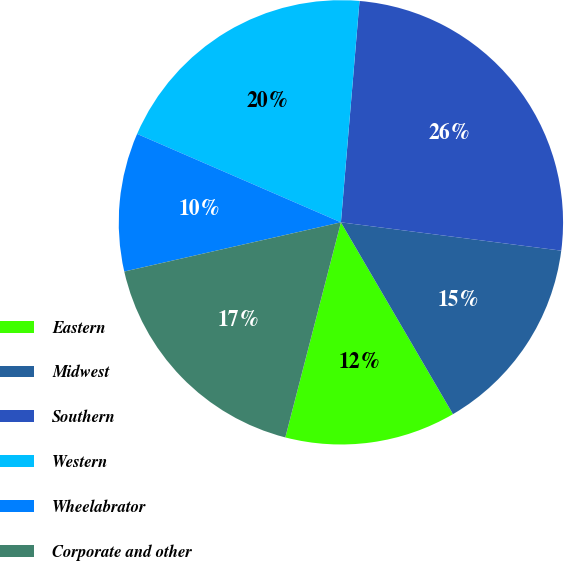<chart> <loc_0><loc_0><loc_500><loc_500><pie_chart><fcel>Eastern<fcel>Midwest<fcel>Southern<fcel>Western<fcel>Wheelabrator<fcel>Corporate and other<nl><fcel>12.44%<fcel>14.55%<fcel>25.7%<fcel>19.82%<fcel>10.07%<fcel>17.42%<nl></chart> 